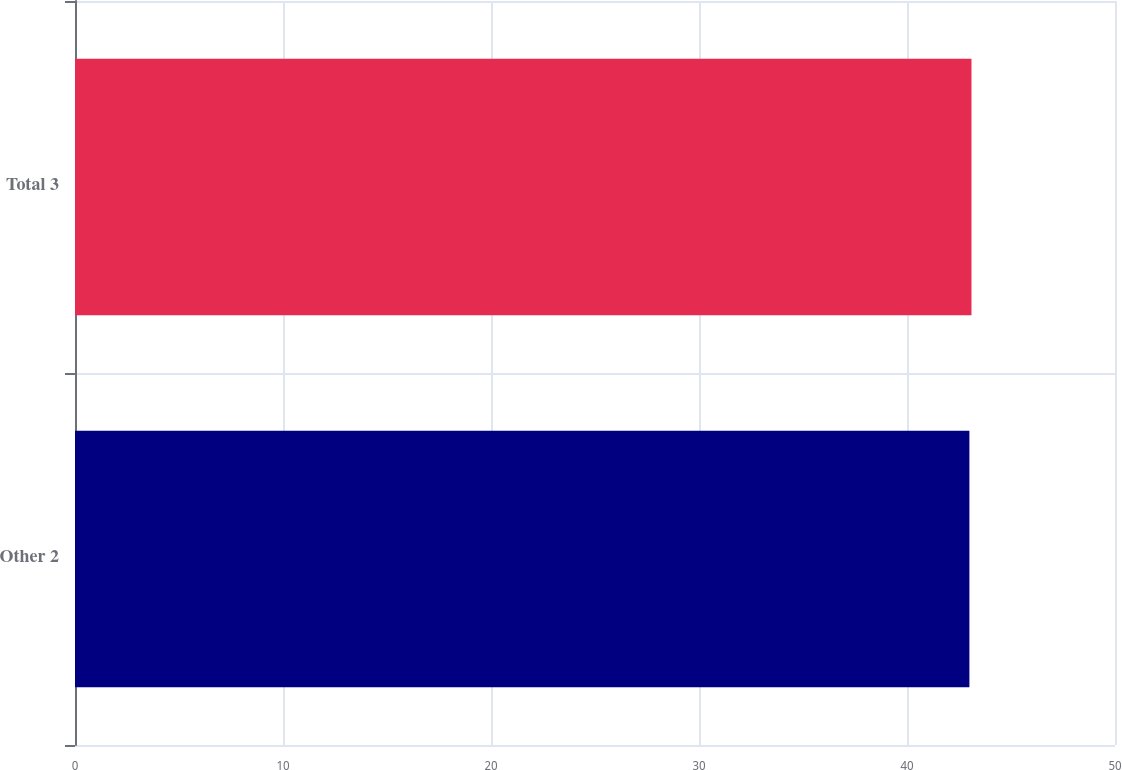<chart> <loc_0><loc_0><loc_500><loc_500><bar_chart><fcel>Other 2<fcel>Total 3<nl><fcel>43<fcel>43.1<nl></chart> 